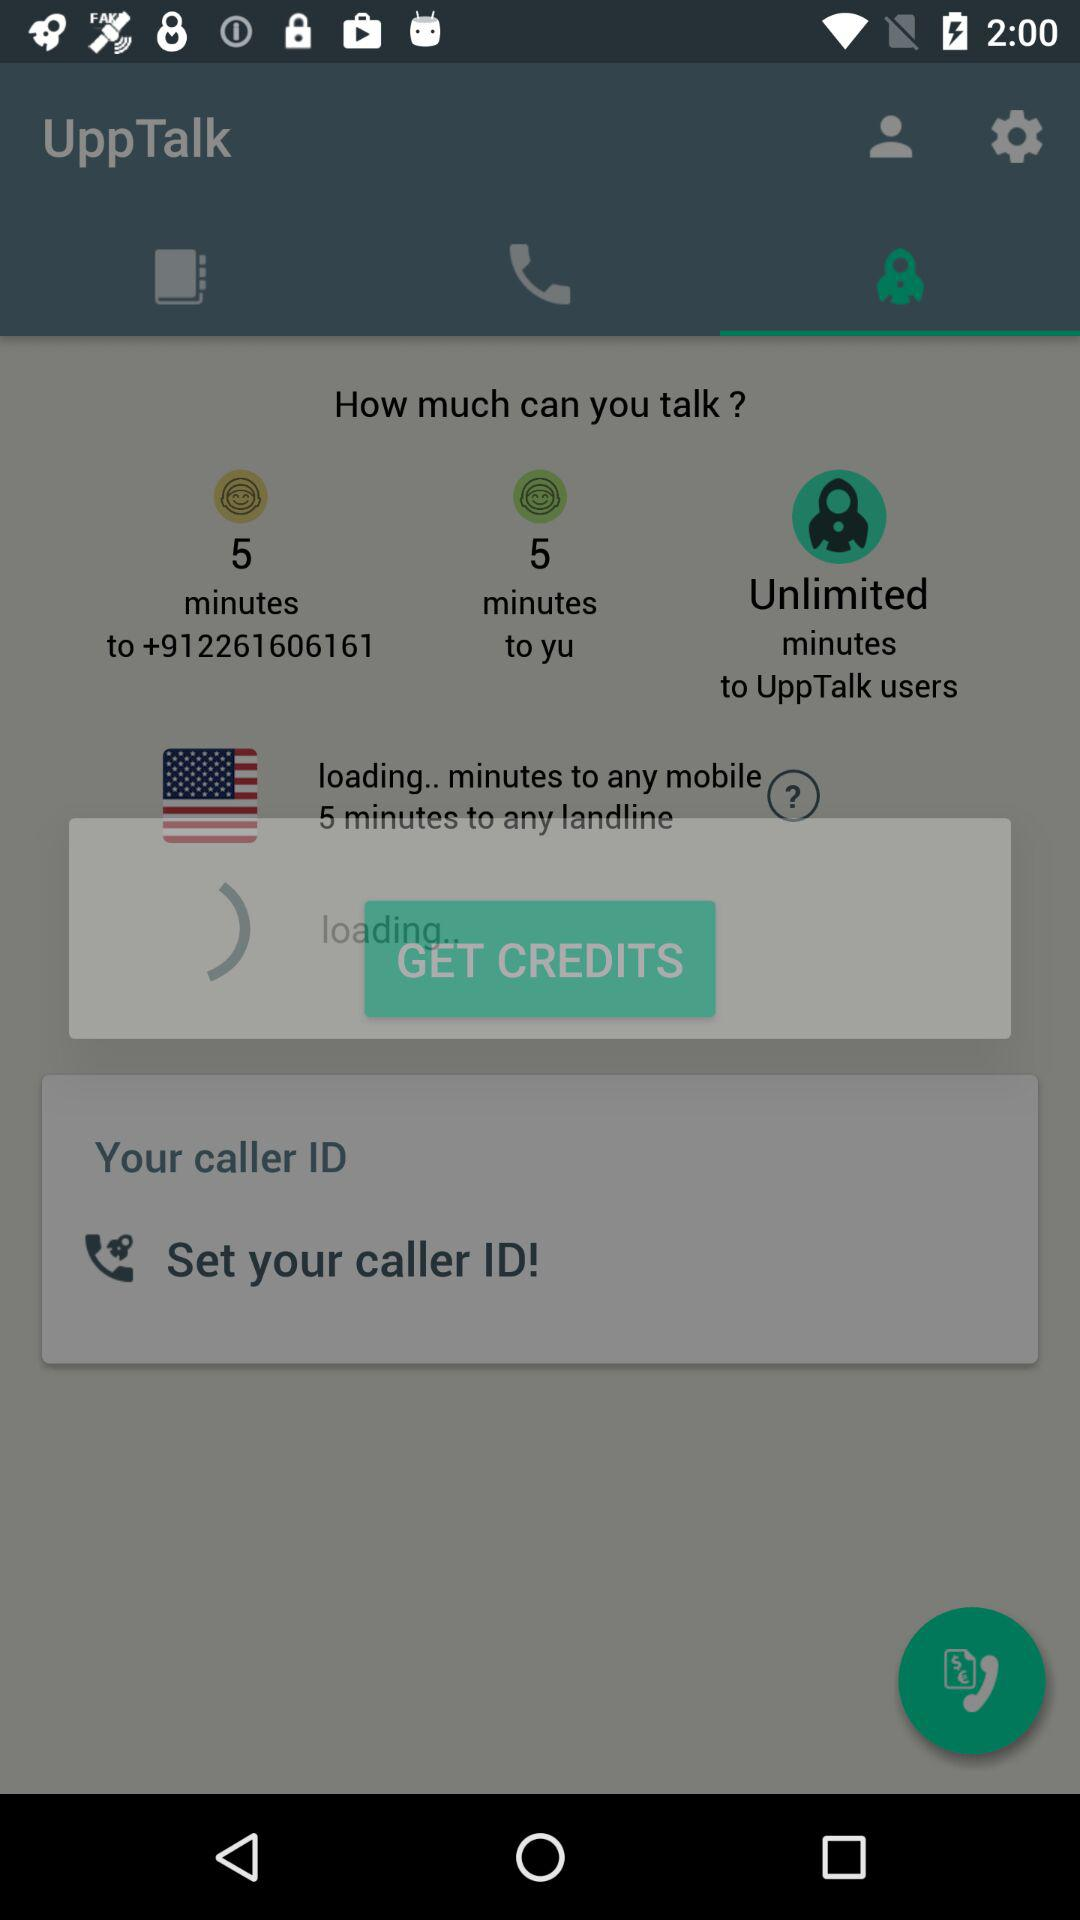How many minutes are available to any landline?
Answer the question using a single word or phrase. 5 minutes 